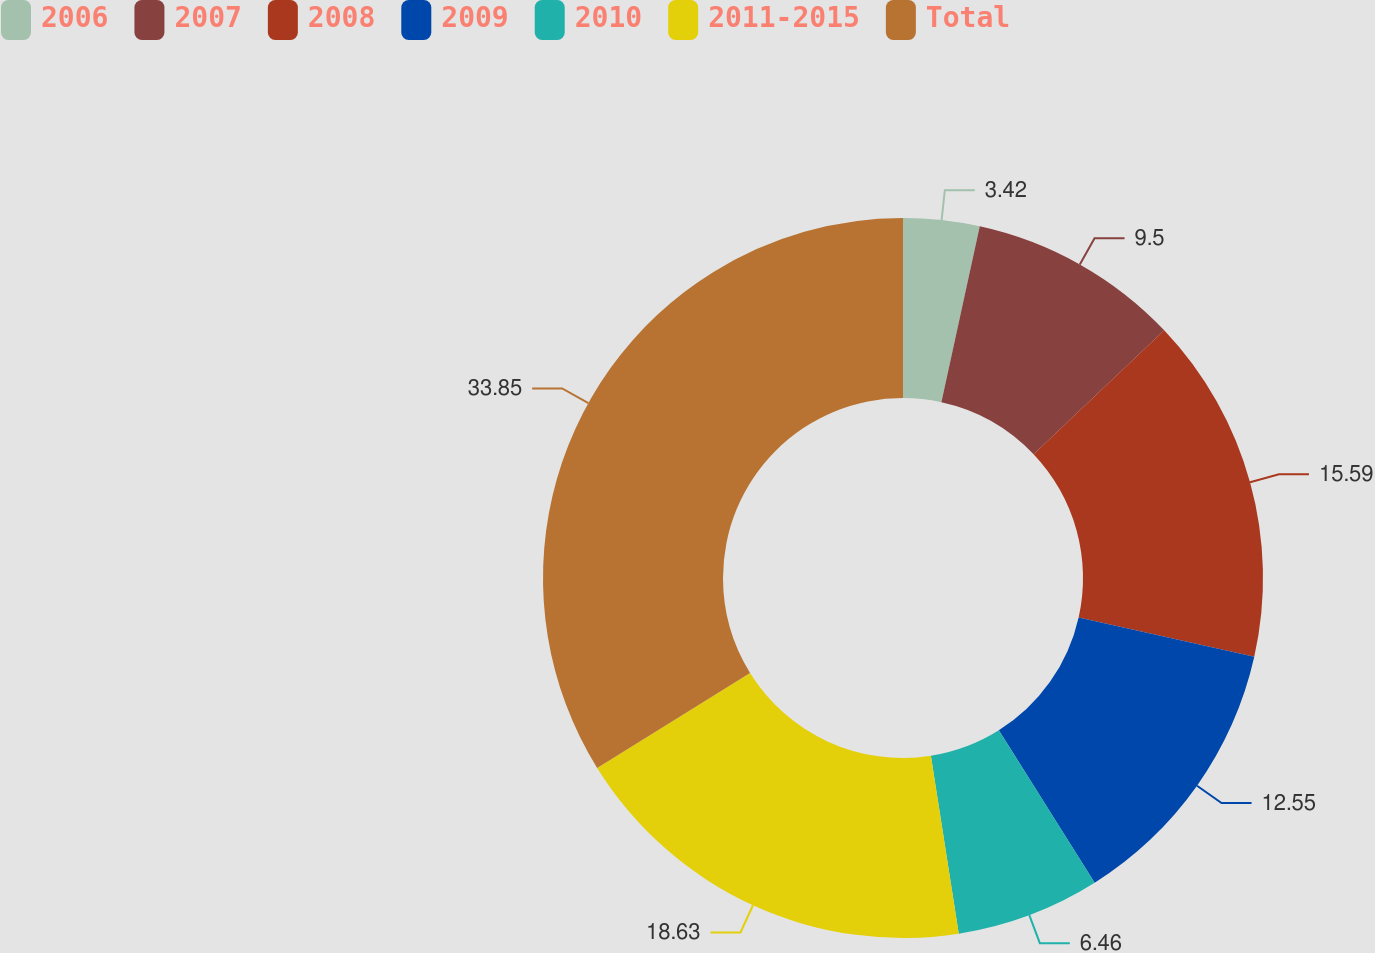Convert chart. <chart><loc_0><loc_0><loc_500><loc_500><pie_chart><fcel>2006<fcel>2007<fcel>2008<fcel>2009<fcel>2010<fcel>2011-2015<fcel>Total<nl><fcel>3.42%<fcel>9.5%<fcel>15.59%<fcel>12.55%<fcel>6.46%<fcel>18.63%<fcel>33.84%<nl></chart> 